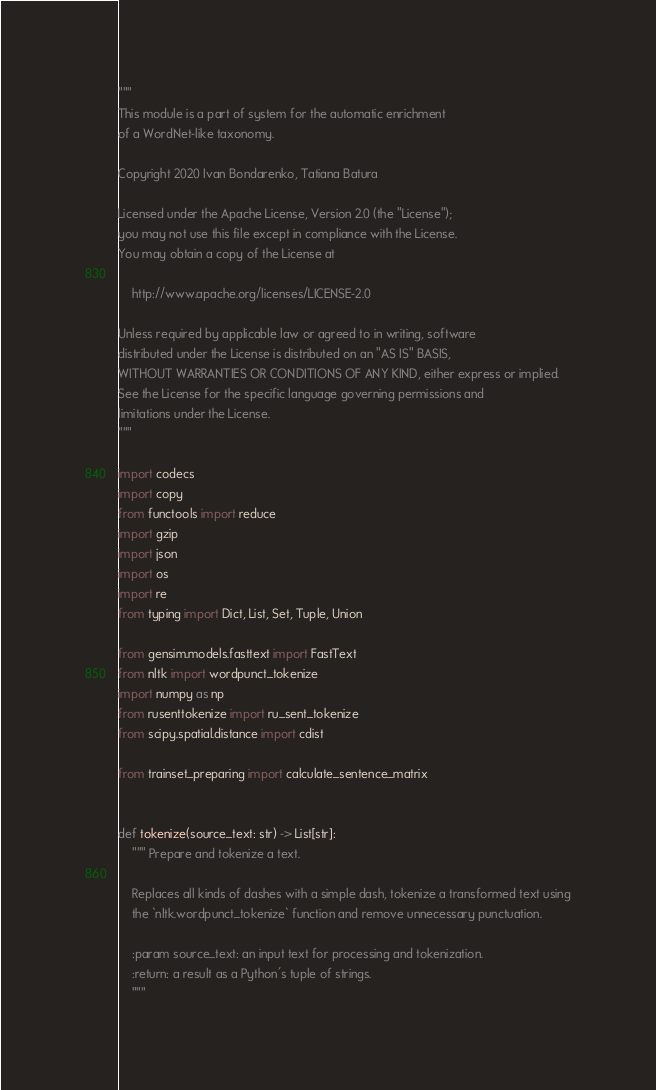Convert code to text. <code><loc_0><loc_0><loc_500><loc_500><_Python_>"""
This module is a part of system for the automatic enrichment
of a WordNet-like taxonomy.

Copyright 2020 Ivan Bondarenko, Tatiana Batura

Licensed under the Apache License, Version 2.0 (the "License");
you may not use this file except in compliance with the License.
You may obtain a copy of the License at

    http://www.apache.org/licenses/LICENSE-2.0

Unless required by applicable law or agreed to in writing, software
distributed under the License is distributed on an "AS IS" BASIS,
WITHOUT WARRANTIES OR CONDITIONS OF ANY KIND, either express or implied.
See the License for the specific language governing permissions and
limitations under the License.
"""

import codecs
import copy
from functools import reduce
import gzip
import json
import os
import re
from typing import Dict, List, Set, Tuple, Union

from gensim.models.fasttext import FastText
from nltk import wordpunct_tokenize
import numpy as np
from rusenttokenize import ru_sent_tokenize
from scipy.spatial.distance import cdist

from trainset_preparing import calculate_sentence_matrix


def tokenize(source_text: str) -> List[str]:
    """ Prepare and tokenize a text.

    Replaces all kinds of dashes with a simple dash, tokenize a transformed text using
    the `nltk.wordpunct_tokenize` function and remove unnecessary punctuation.

    :param source_text: an input text for processing and tokenization.
    :return: a result as a Python's tuple of strings.
    """</code> 